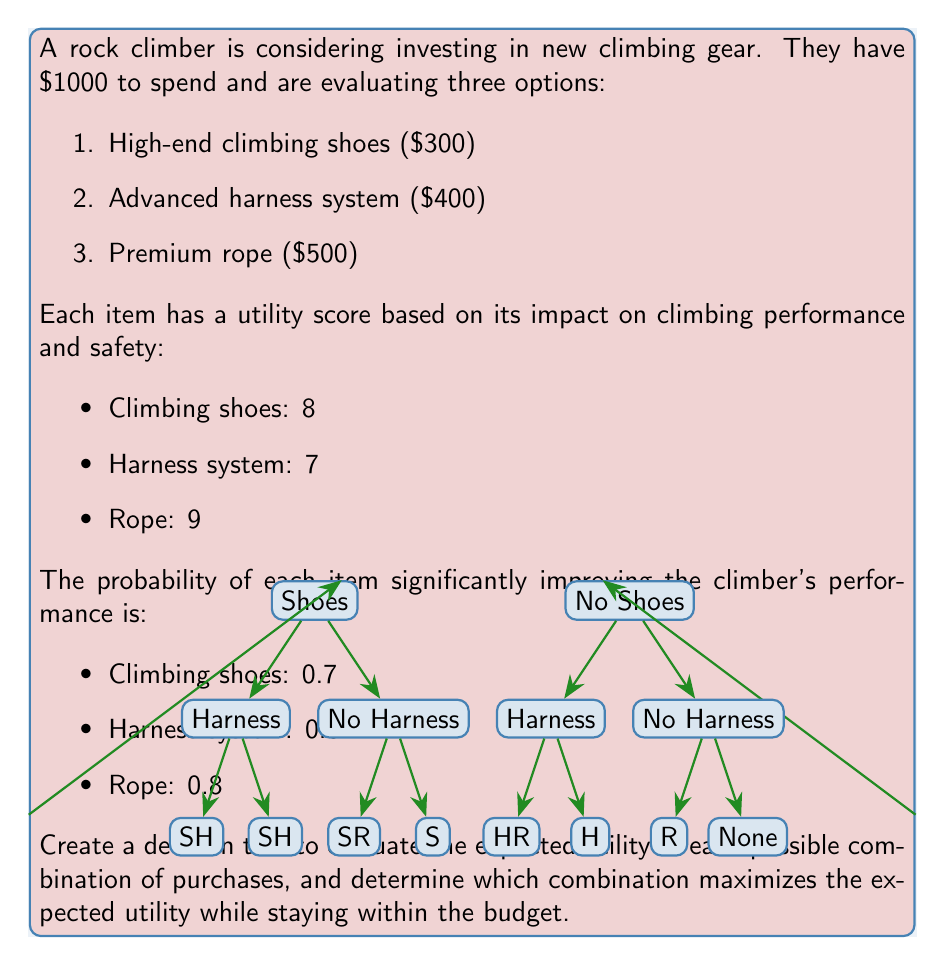Help me with this question. Let's approach this problem step-by-step:

1) First, we need to calculate the expected utility for each item:

   Shoes: $EU_S = 8 \times 0.7 = 5.6$
   Harness: $EU_H = 7 \times 0.6 = 4.2$
   Rope: $EU_R = 9 \times 0.8 = 7.2$

2) Now, let's list all possible combinations within the budget:

   a) Shoes only: $300
   b) Harness only: $400
   c) Rope only: $500
   d) Shoes + Harness: $700
   e) Shoes + Rope: $800

3) Calculate the expected utility for each combination:

   a) $EU_{S} = 5.6$
   b) $EU_{H} = 4.2$
   c) $EU_{R} = 7.2$
   d) $EU_{SH} = 5.6 + 4.2 = 9.8$
   e) $EU_{SR} = 5.6 + 7.2 = 12.8$

4) The decision tree helps visualize these options:

   - The first branch represents the choice of buying shoes or not.
   - The second branch represents the choice of buying a harness or not.
   - The third branch (only shown for the "Shoes" option due to budget constraints) represents the choice of buying a rope or not.

5) By following the branches and summing the expected utilities, we can see that the combination of Shoes + Rope (SR) gives the highest expected utility of 12.8.

6) This combination also stays within the budget ($300 + $500 = $800 < $1000).

Therefore, the optimal decision is to purchase the high-end climbing shoes and the premium rope.
Answer: Purchase climbing shoes and rope for a maximum expected utility of 12.8. 